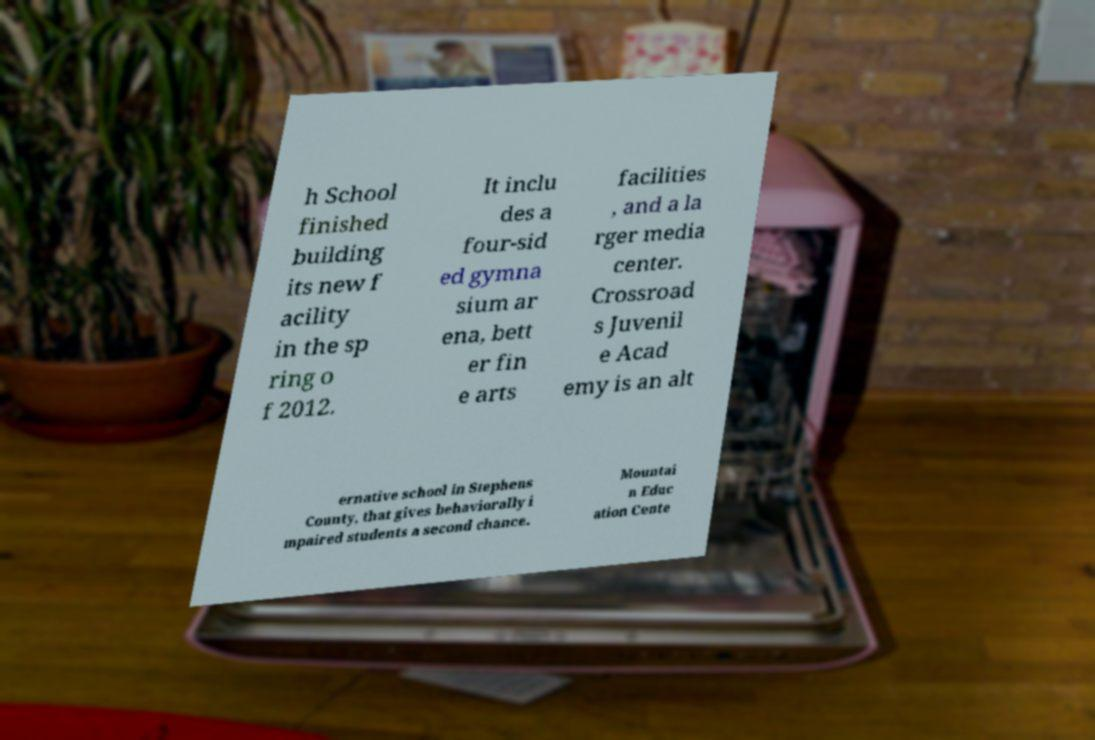Could you assist in decoding the text presented in this image and type it out clearly? h School finished building its new f acility in the sp ring o f 2012. It inclu des a four-sid ed gymna sium ar ena, bett er fin e arts facilities , and a la rger media center. Crossroad s Juvenil e Acad emy is an alt ernative school in Stephens County, that gives behaviorally i mpaired students a second chance. Mountai n Educ ation Cente 